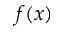Convert formula to latex. <formula><loc_0><loc_0><loc_500><loc_500>f ( x )</formula> 